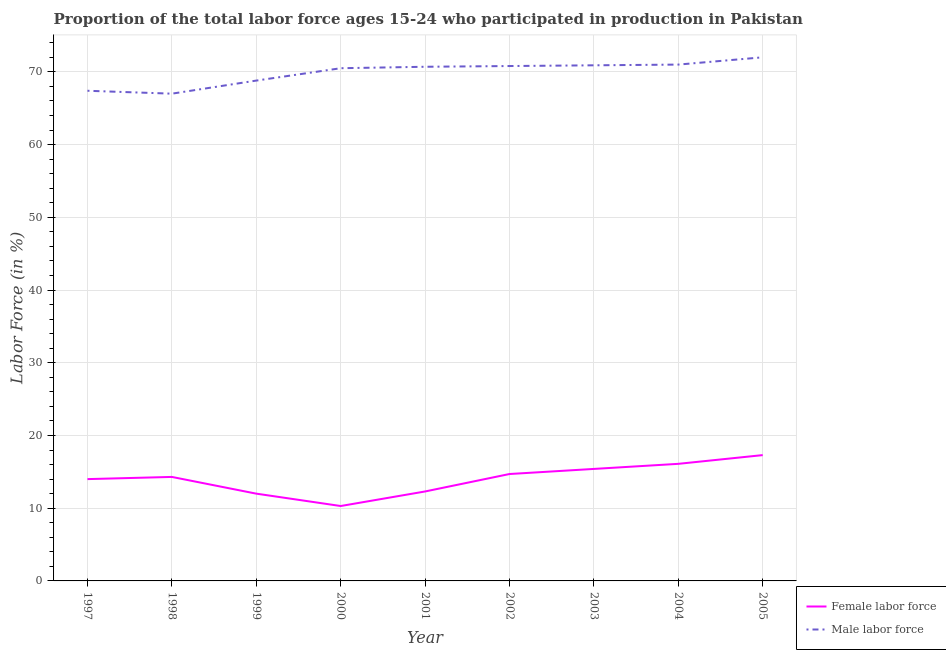How many different coloured lines are there?
Ensure brevity in your answer.  2. Does the line corresponding to percentage of male labour force intersect with the line corresponding to percentage of female labor force?
Make the answer very short. No. Is the number of lines equal to the number of legend labels?
Provide a succinct answer. Yes. What is the percentage of female labor force in 2005?
Provide a succinct answer. 17.3. Across all years, what is the maximum percentage of female labor force?
Make the answer very short. 17.3. Across all years, what is the minimum percentage of female labor force?
Ensure brevity in your answer.  10.3. In which year was the percentage of female labor force maximum?
Your answer should be compact. 2005. In which year was the percentage of female labor force minimum?
Offer a very short reply. 2000. What is the total percentage of male labour force in the graph?
Your response must be concise. 629.1. What is the difference between the percentage of female labor force in 1998 and that in 2003?
Provide a succinct answer. -1.1. What is the difference between the percentage of female labor force in 1999 and the percentage of male labour force in 1997?
Give a very brief answer. -55.4. What is the average percentage of male labour force per year?
Your answer should be very brief. 69.9. In the year 1999, what is the difference between the percentage of male labour force and percentage of female labor force?
Keep it short and to the point. 56.8. In how many years, is the percentage of female labor force greater than 46 %?
Provide a short and direct response. 0. What is the ratio of the percentage of female labor force in 2000 to that in 2005?
Keep it short and to the point. 0.6. Is the difference between the percentage of male labour force in 2000 and 2005 greater than the difference between the percentage of female labor force in 2000 and 2005?
Keep it short and to the point. Yes. What is the difference between the highest and the second highest percentage of female labor force?
Ensure brevity in your answer.  1.2. What is the difference between the highest and the lowest percentage of male labour force?
Provide a short and direct response. 5. In how many years, is the percentage of male labour force greater than the average percentage of male labour force taken over all years?
Offer a very short reply. 6. Is the percentage of female labor force strictly less than the percentage of male labour force over the years?
Ensure brevity in your answer.  Yes. How many lines are there?
Your response must be concise. 2. How many years are there in the graph?
Provide a short and direct response. 9. Does the graph contain any zero values?
Keep it short and to the point. No. Where does the legend appear in the graph?
Your response must be concise. Bottom right. What is the title of the graph?
Offer a very short reply. Proportion of the total labor force ages 15-24 who participated in production in Pakistan. What is the Labor Force (in %) of Male labor force in 1997?
Keep it short and to the point. 67.4. What is the Labor Force (in %) in Female labor force in 1998?
Make the answer very short. 14.3. What is the Labor Force (in %) in Male labor force in 1998?
Provide a succinct answer. 67. What is the Labor Force (in %) of Male labor force in 1999?
Keep it short and to the point. 68.8. What is the Labor Force (in %) of Female labor force in 2000?
Provide a succinct answer. 10.3. What is the Labor Force (in %) of Male labor force in 2000?
Your answer should be compact. 70.5. What is the Labor Force (in %) in Female labor force in 2001?
Offer a very short reply. 12.3. What is the Labor Force (in %) in Male labor force in 2001?
Your answer should be compact. 70.7. What is the Labor Force (in %) of Female labor force in 2002?
Offer a terse response. 14.7. What is the Labor Force (in %) in Male labor force in 2002?
Provide a short and direct response. 70.8. What is the Labor Force (in %) of Female labor force in 2003?
Keep it short and to the point. 15.4. What is the Labor Force (in %) in Male labor force in 2003?
Provide a succinct answer. 70.9. What is the Labor Force (in %) of Female labor force in 2004?
Give a very brief answer. 16.1. What is the Labor Force (in %) in Male labor force in 2004?
Your answer should be very brief. 71. What is the Labor Force (in %) in Female labor force in 2005?
Keep it short and to the point. 17.3. Across all years, what is the maximum Labor Force (in %) of Female labor force?
Provide a succinct answer. 17.3. Across all years, what is the maximum Labor Force (in %) in Male labor force?
Provide a short and direct response. 72. Across all years, what is the minimum Labor Force (in %) in Female labor force?
Provide a short and direct response. 10.3. Across all years, what is the minimum Labor Force (in %) of Male labor force?
Offer a terse response. 67. What is the total Labor Force (in %) in Female labor force in the graph?
Keep it short and to the point. 126.4. What is the total Labor Force (in %) in Male labor force in the graph?
Your answer should be compact. 629.1. What is the difference between the Labor Force (in %) of Female labor force in 1997 and that in 2000?
Offer a very short reply. 3.7. What is the difference between the Labor Force (in %) in Male labor force in 1997 and that in 2000?
Offer a very short reply. -3.1. What is the difference between the Labor Force (in %) in Female labor force in 1997 and that in 2001?
Ensure brevity in your answer.  1.7. What is the difference between the Labor Force (in %) of Male labor force in 1997 and that in 2001?
Provide a short and direct response. -3.3. What is the difference between the Labor Force (in %) in Female labor force in 1998 and that in 2002?
Ensure brevity in your answer.  -0.4. What is the difference between the Labor Force (in %) in Female labor force in 1998 and that in 2004?
Ensure brevity in your answer.  -1.8. What is the difference between the Labor Force (in %) in Male labor force in 1998 and that in 2004?
Your response must be concise. -4. What is the difference between the Labor Force (in %) in Male labor force in 1998 and that in 2005?
Ensure brevity in your answer.  -5. What is the difference between the Labor Force (in %) of Male labor force in 1999 and that in 2000?
Provide a short and direct response. -1.7. What is the difference between the Labor Force (in %) of Female labor force in 1999 and that in 2001?
Your answer should be very brief. -0.3. What is the difference between the Labor Force (in %) of Male labor force in 1999 and that in 2001?
Your answer should be very brief. -1.9. What is the difference between the Labor Force (in %) of Female labor force in 1999 and that in 2002?
Your answer should be very brief. -2.7. What is the difference between the Labor Force (in %) of Male labor force in 1999 and that in 2002?
Your answer should be very brief. -2. What is the difference between the Labor Force (in %) of Male labor force in 1999 and that in 2003?
Make the answer very short. -2.1. What is the difference between the Labor Force (in %) in Female labor force in 1999 and that in 2004?
Offer a terse response. -4.1. What is the difference between the Labor Force (in %) in Male labor force in 1999 and that in 2004?
Keep it short and to the point. -2.2. What is the difference between the Labor Force (in %) in Male labor force in 1999 and that in 2005?
Offer a terse response. -3.2. What is the difference between the Labor Force (in %) of Female labor force in 2000 and that in 2003?
Ensure brevity in your answer.  -5.1. What is the difference between the Labor Force (in %) of Male labor force in 2000 and that in 2003?
Your answer should be very brief. -0.4. What is the difference between the Labor Force (in %) in Female labor force in 2000 and that in 2004?
Keep it short and to the point. -5.8. What is the difference between the Labor Force (in %) in Male labor force in 2000 and that in 2004?
Offer a very short reply. -0.5. What is the difference between the Labor Force (in %) in Female labor force in 2000 and that in 2005?
Your response must be concise. -7. What is the difference between the Labor Force (in %) of Female labor force in 2001 and that in 2002?
Provide a succinct answer. -2.4. What is the difference between the Labor Force (in %) of Male labor force in 2001 and that in 2002?
Offer a very short reply. -0.1. What is the difference between the Labor Force (in %) of Female labor force in 2001 and that in 2004?
Provide a succinct answer. -3.8. What is the difference between the Labor Force (in %) of Male labor force in 2001 and that in 2005?
Provide a succinct answer. -1.3. What is the difference between the Labor Force (in %) of Female labor force in 2002 and that in 2003?
Keep it short and to the point. -0.7. What is the difference between the Labor Force (in %) in Male labor force in 2002 and that in 2003?
Give a very brief answer. -0.1. What is the difference between the Labor Force (in %) of Male labor force in 2002 and that in 2004?
Your answer should be very brief. -0.2. What is the difference between the Labor Force (in %) in Female labor force in 2002 and that in 2005?
Make the answer very short. -2.6. What is the difference between the Labor Force (in %) in Male labor force in 2003 and that in 2004?
Give a very brief answer. -0.1. What is the difference between the Labor Force (in %) of Male labor force in 2003 and that in 2005?
Keep it short and to the point. -1.1. What is the difference between the Labor Force (in %) of Female labor force in 1997 and the Labor Force (in %) of Male labor force in 1998?
Your answer should be very brief. -53. What is the difference between the Labor Force (in %) of Female labor force in 1997 and the Labor Force (in %) of Male labor force in 1999?
Your response must be concise. -54.8. What is the difference between the Labor Force (in %) in Female labor force in 1997 and the Labor Force (in %) in Male labor force in 2000?
Your answer should be compact. -56.5. What is the difference between the Labor Force (in %) in Female labor force in 1997 and the Labor Force (in %) in Male labor force in 2001?
Ensure brevity in your answer.  -56.7. What is the difference between the Labor Force (in %) of Female labor force in 1997 and the Labor Force (in %) of Male labor force in 2002?
Provide a short and direct response. -56.8. What is the difference between the Labor Force (in %) of Female labor force in 1997 and the Labor Force (in %) of Male labor force in 2003?
Your answer should be very brief. -56.9. What is the difference between the Labor Force (in %) in Female labor force in 1997 and the Labor Force (in %) in Male labor force in 2004?
Ensure brevity in your answer.  -57. What is the difference between the Labor Force (in %) in Female labor force in 1997 and the Labor Force (in %) in Male labor force in 2005?
Provide a succinct answer. -58. What is the difference between the Labor Force (in %) in Female labor force in 1998 and the Labor Force (in %) in Male labor force in 1999?
Your response must be concise. -54.5. What is the difference between the Labor Force (in %) in Female labor force in 1998 and the Labor Force (in %) in Male labor force in 2000?
Your response must be concise. -56.2. What is the difference between the Labor Force (in %) of Female labor force in 1998 and the Labor Force (in %) of Male labor force in 2001?
Your answer should be compact. -56.4. What is the difference between the Labor Force (in %) of Female labor force in 1998 and the Labor Force (in %) of Male labor force in 2002?
Offer a terse response. -56.5. What is the difference between the Labor Force (in %) of Female labor force in 1998 and the Labor Force (in %) of Male labor force in 2003?
Keep it short and to the point. -56.6. What is the difference between the Labor Force (in %) of Female labor force in 1998 and the Labor Force (in %) of Male labor force in 2004?
Your response must be concise. -56.7. What is the difference between the Labor Force (in %) in Female labor force in 1998 and the Labor Force (in %) in Male labor force in 2005?
Offer a terse response. -57.7. What is the difference between the Labor Force (in %) in Female labor force in 1999 and the Labor Force (in %) in Male labor force in 2000?
Give a very brief answer. -58.5. What is the difference between the Labor Force (in %) of Female labor force in 1999 and the Labor Force (in %) of Male labor force in 2001?
Make the answer very short. -58.7. What is the difference between the Labor Force (in %) of Female labor force in 1999 and the Labor Force (in %) of Male labor force in 2002?
Offer a terse response. -58.8. What is the difference between the Labor Force (in %) of Female labor force in 1999 and the Labor Force (in %) of Male labor force in 2003?
Make the answer very short. -58.9. What is the difference between the Labor Force (in %) of Female labor force in 1999 and the Labor Force (in %) of Male labor force in 2004?
Provide a short and direct response. -59. What is the difference between the Labor Force (in %) of Female labor force in 1999 and the Labor Force (in %) of Male labor force in 2005?
Provide a short and direct response. -60. What is the difference between the Labor Force (in %) in Female labor force in 2000 and the Labor Force (in %) in Male labor force in 2001?
Make the answer very short. -60.4. What is the difference between the Labor Force (in %) in Female labor force in 2000 and the Labor Force (in %) in Male labor force in 2002?
Your answer should be very brief. -60.5. What is the difference between the Labor Force (in %) of Female labor force in 2000 and the Labor Force (in %) of Male labor force in 2003?
Give a very brief answer. -60.6. What is the difference between the Labor Force (in %) of Female labor force in 2000 and the Labor Force (in %) of Male labor force in 2004?
Your response must be concise. -60.7. What is the difference between the Labor Force (in %) in Female labor force in 2000 and the Labor Force (in %) in Male labor force in 2005?
Give a very brief answer. -61.7. What is the difference between the Labor Force (in %) in Female labor force in 2001 and the Labor Force (in %) in Male labor force in 2002?
Keep it short and to the point. -58.5. What is the difference between the Labor Force (in %) of Female labor force in 2001 and the Labor Force (in %) of Male labor force in 2003?
Offer a terse response. -58.6. What is the difference between the Labor Force (in %) of Female labor force in 2001 and the Labor Force (in %) of Male labor force in 2004?
Offer a terse response. -58.7. What is the difference between the Labor Force (in %) of Female labor force in 2001 and the Labor Force (in %) of Male labor force in 2005?
Give a very brief answer. -59.7. What is the difference between the Labor Force (in %) of Female labor force in 2002 and the Labor Force (in %) of Male labor force in 2003?
Offer a terse response. -56.2. What is the difference between the Labor Force (in %) in Female labor force in 2002 and the Labor Force (in %) in Male labor force in 2004?
Provide a succinct answer. -56.3. What is the difference between the Labor Force (in %) of Female labor force in 2002 and the Labor Force (in %) of Male labor force in 2005?
Provide a succinct answer. -57.3. What is the difference between the Labor Force (in %) in Female labor force in 2003 and the Labor Force (in %) in Male labor force in 2004?
Keep it short and to the point. -55.6. What is the difference between the Labor Force (in %) of Female labor force in 2003 and the Labor Force (in %) of Male labor force in 2005?
Give a very brief answer. -56.6. What is the difference between the Labor Force (in %) of Female labor force in 2004 and the Labor Force (in %) of Male labor force in 2005?
Your answer should be very brief. -55.9. What is the average Labor Force (in %) of Female labor force per year?
Your response must be concise. 14.04. What is the average Labor Force (in %) in Male labor force per year?
Provide a short and direct response. 69.9. In the year 1997, what is the difference between the Labor Force (in %) in Female labor force and Labor Force (in %) in Male labor force?
Make the answer very short. -53.4. In the year 1998, what is the difference between the Labor Force (in %) in Female labor force and Labor Force (in %) in Male labor force?
Ensure brevity in your answer.  -52.7. In the year 1999, what is the difference between the Labor Force (in %) of Female labor force and Labor Force (in %) of Male labor force?
Your response must be concise. -56.8. In the year 2000, what is the difference between the Labor Force (in %) of Female labor force and Labor Force (in %) of Male labor force?
Ensure brevity in your answer.  -60.2. In the year 2001, what is the difference between the Labor Force (in %) of Female labor force and Labor Force (in %) of Male labor force?
Offer a terse response. -58.4. In the year 2002, what is the difference between the Labor Force (in %) in Female labor force and Labor Force (in %) in Male labor force?
Your answer should be very brief. -56.1. In the year 2003, what is the difference between the Labor Force (in %) of Female labor force and Labor Force (in %) of Male labor force?
Keep it short and to the point. -55.5. In the year 2004, what is the difference between the Labor Force (in %) in Female labor force and Labor Force (in %) in Male labor force?
Offer a terse response. -54.9. In the year 2005, what is the difference between the Labor Force (in %) of Female labor force and Labor Force (in %) of Male labor force?
Provide a succinct answer. -54.7. What is the ratio of the Labor Force (in %) of Male labor force in 1997 to that in 1998?
Ensure brevity in your answer.  1.01. What is the ratio of the Labor Force (in %) of Male labor force in 1997 to that in 1999?
Offer a terse response. 0.98. What is the ratio of the Labor Force (in %) of Female labor force in 1997 to that in 2000?
Your answer should be very brief. 1.36. What is the ratio of the Labor Force (in %) of Male labor force in 1997 to that in 2000?
Your response must be concise. 0.96. What is the ratio of the Labor Force (in %) in Female labor force in 1997 to that in 2001?
Make the answer very short. 1.14. What is the ratio of the Labor Force (in %) of Male labor force in 1997 to that in 2001?
Your answer should be compact. 0.95. What is the ratio of the Labor Force (in %) of Female labor force in 1997 to that in 2002?
Make the answer very short. 0.95. What is the ratio of the Labor Force (in %) of Male labor force in 1997 to that in 2002?
Give a very brief answer. 0.95. What is the ratio of the Labor Force (in %) of Male labor force in 1997 to that in 2003?
Ensure brevity in your answer.  0.95. What is the ratio of the Labor Force (in %) in Female labor force in 1997 to that in 2004?
Provide a short and direct response. 0.87. What is the ratio of the Labor Force (in %) of Male labor force in 1997 to that in 2004?
Keep it short and to the point. 0.95. What is the ratio of the Labor Force (in %) in Female labor force in 1997 to that in 2005?
Your answer should be very brief. 0.81. What is the ratio of the Labor Force (in %) of Male labor force in 1997 to that in 2005?
Your answer should be compact. 0.94. What is the ratio of the Labor Force (in %) in Female labor force in 1998 to that in 1999?
Ensure brevity in your answer.  1.19. What is the ratio of the Labor Force (in %) of Male labor force in 1998 to that in 1999?
Offer a terse response. 0.97. What is the ratio of the Labor Force (in %) of Female labor force in 1998 to that in 2000?
Provide a short and direct response. 1.39. What is the ratio of the Labor Force (in %) in Male labor force in 1998 to that in 2000?
Offer a terse response. 0.95. What is the ratio of the Labor Force (in %) in Female labor force in 1998 to that in 2001?
Provide a succinct answer. 1.16. What is the ratio of the Labor Force (in %) in Male labor force in 1998 to that in 2001?
Your response must be concise. 0.95. What is the ratio of the Labor Force (in %) in Female labor force in 1998 to that in 2002?
Offer a very short reply. 0.97. What is the ratio of the Labor Force (in %) in Male labor force in 1998 to that in 2002?
Keep it short and to the point. 0.95. What is the ratio of the Labor Force (in %) of Male labor force in 1998 to that in 2003?
Provide a succinct answer. 0.94. What is the ratio of the Labor Force (in %) in Female labor force in 1998 to that in 2004?
Your answer should be very brief. 0.89. What is the ratio of the Labor Force (in %) of Male labor force in 1998 to that in 2004?
Keep it short and to the point. 0.94. What is the ratio of the Labor Force (in %) in Female labor force in 1998 to that in 2005?
Provide a short and direct response. 0.83. What is the ratio of the Labor Force (in %) in Male labor force in 1998 to that in 2005?
Offer a terse response. 0.93. What is the ratio of the Labor Force (in %) in Female labor force in 1999 to that in 2000?
Provide a succinct answer. 1.17. What is the ratio of the Labor Force (in %) of Male labor force in 1999 to that in 2000?
Provide a short and direct response. 0.98. What is the ratio of the Labor Force (in %) in Female labor force in 1999 to that in 2001?
Keep it short and to the point. 0.98. What is the ratio of the Labor Force (in %) of Male labor force in 1999 to that in 2001?
Your response must be concise. 0.97. What is the ratio of the Labor Force (in %) in Female labor force in 1999 to that in 2002?
Offer a terse response. 0.82. What is the ratio of the Labor Force (in %) in Male labor force in 1999 to that in 2002?
Provide a short and direct response. 0.97. What is the ratio of the Labor Force (in %) of Female labor force in 1999 to that in 2003?
Provide a succinct answer. 0.78. What is the ratio of the Labor Force (in %) of Male labor force in 1999 to that in 2003?
Your answer should be compact. 0.97. What is the ratio of the Labor Force (in %) in Female labor force in 1999 to that in 2004?
Provide a succinct answer. 0.75. What is the ratio of the Labor Force (in %) in Male labor force in 1999 to that in 2004?
Make the answer very short. 0.97. What is the ratio of the Labor Force (in %) of Female labor force in 1999 to that in 2005?
Offer a very short reply. 0.69. What is the ratio of the Labor Force (in %) in Male labor force in 1999 to that in 2005?
Keep it short and to the point. 0.96. What is the ratio of the Labor Force (in %) in Female labor force in 2000 to that in 2001?
Your response must be concise. 0.84. What is the ratio of the Labor Force (in %) in Female labor force in 2000 to that in 2002?
Your answer should be compact. 0.7. What is the ratio of the Labor Force (in %) of Male labor force in 2000 to that in 2002?
Provide a succinct answer. 1. What is the ratio of the Labor Force (in %) of Female labor force in 2000 to that in 2003?
Your answer should be very brief. 0.67. What is the ratio of the Labor Force (in %) in Female labor force in 2000 to that in 2004?
Give a very brief answer. 0.64. What is the ratio of the Labor Force (in %) in Female labor force in 2000 to that in 2005?
Your answer should be very brief. 0.6. What is the ratio of the Labor Force (in %) in Male labor force in 2000 to that in 2005?
Ensure brevity in your answer.  0.98. What is the ratio of the Labor Force (in %) of Female labor force in 2001 to that in 2002?
Keep it short and to the point. 0.84. What is the ratio of the Labor Force (in %) of Female labor force in 2001 to that in 2003?
Your answer should be compact. 0.8. What is the ratio of the Labor Force (in %) in Female labor force in 2001 to that in 2004?
Your response must be concise. 0.76. What is the ratio of the Labor Force (in %) in Male labor force in 2001 to that in 2004?
Offer a terse response. 1. What is the ratio of the Labor Force (in %) of Female labor force in 2001 to that in 2005?
Your answer should be very brief. 0.71. What is the ratio of the Labor Force (in %) of Male labor force in 2001 to that in 2005?
Provide a short and direct response. 0.98. What is the ratio of the Labor Force (in %) of Female labor force in 2002 to that in 2003?
Offer a terse response. 0.95. What is the ratio of the Labor Force (in %) of Male labor force in 2002 to that in 2003?
Your response must be concise. 1. What is the ratio of the Labor Force (in %) of Female labor force in 2002 to that in 2004?
Make the answer very short. 0.91. What is the ratio of the Labor Force (in %) of Female labor force in 2002 to that in 2005?
Offer a very short reply. 0.85. What is the ratio of the Labor Force (in %) of Male labor force in 2002 to that in 2005?
Your answer should be very brief. 0.98. What is the ratio of the Labor Force (in %) in Female labor force in 2003 to that in 2004?
Provide a short and direct response. 0.96. What is the ratio of the Labor Force (in %) of Male labor force in 2003 to that in 2004?
Give a very brief answer. 1. What is the ratio of the Labor Force (in %) in Female labor force in 2003 to that in 2005?
Provide a short and direct response. 0.89. What is the ratio of the Labor Force (in %) in Male labor force in 2003 to that in 2005?
Your answer should be very brief. 0.98. What is the ratio of the Labor Force (in %) of Female labor force in 2004 to that in 2005?
Make the answer very short. 0.93. What is the ratio of the Labor Force (in %) in Male labor force in 2004 to that in 2005?
Provide a short and direct response. 0.99. What is the difference between the highest and the second highest Labor Force (in %) in Female labor force?
Offer a very short reply. 1.2. What is the difference between the highest and the lowest Labor Force (in %) in Female labor force?
Your response must be concise. 7. 